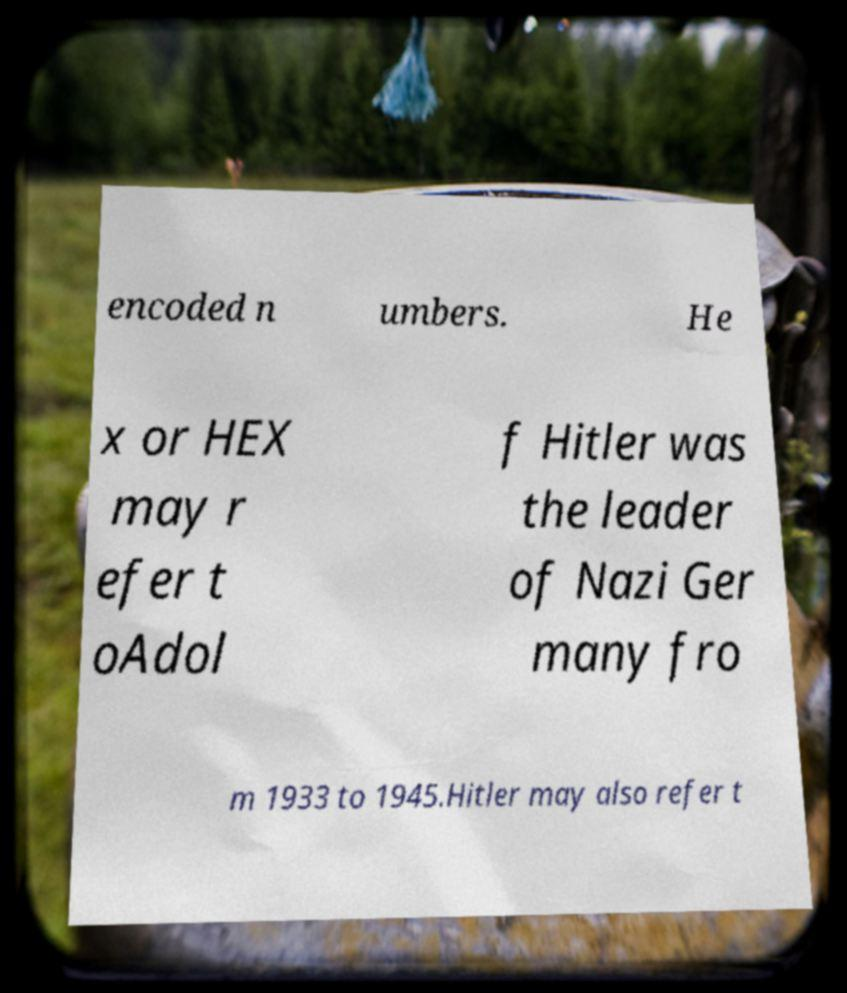Please read and relay the text visible in this image. What does it say? encoded n umbers. He x or HEX may r efer t oAdol f Hitler was the leader of Nazi Ger many fro m 1933 to 1945.Hitler may also refer t 